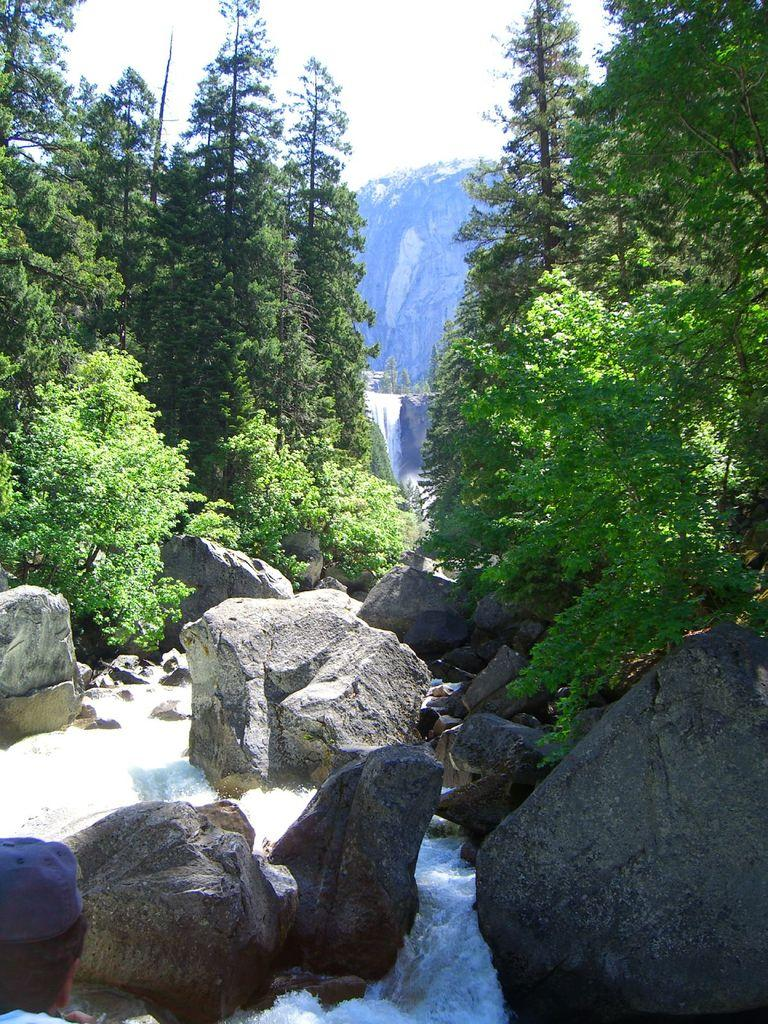What type of vegetation can be seen in the image? There is a group of trees in the image. What other natural elements are present in the image? There are rocks and water visible in the image. How is the water situated in the image? The water flows on a hill in the background. What is visible in the background of the image? The sky is visible in the background. What is the weather like in the image? The sky appears cloudy in the image. What type of curtain is hanging from the trees in the image? There are no curtains present in the image; it features a group of trees, rocks, water, and a cloudy sky. How many legs can be seen supporting the rocks in the image? There are no legs visible in the image; it features a group of trees, rocks, water, and a cloudy sky. 